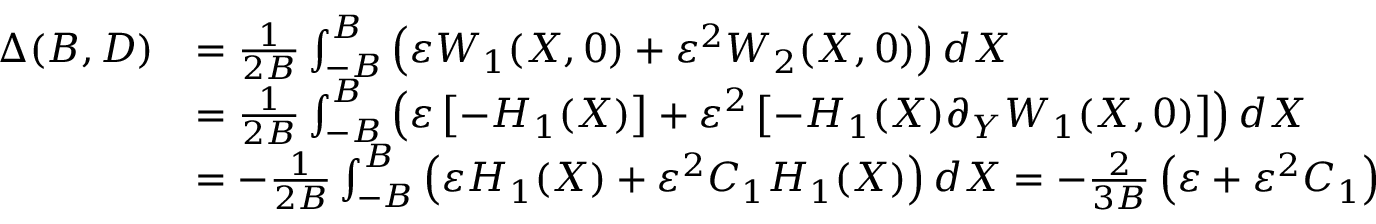<formula> <loc_0><loc_0><loc_500><loc_500>\begin{array} { r l } { \Delta ( B , D ) } & { = \frac { 1 } { 2 B } \int _ { - B } ^ { B } \left ( \varepsilon W _ { 1 } ( X , 0 ) + \varepsilon ^ { 2 } W _ { 2 } ( X , 0 ) \right ) d X } \\ & { = \frac { 1 } { 2 B } \int _ { - B } ^ { B } \left ( \varepsilon \left [ - H _ { 1 } ( X ) \right ] + \varepsilon ^ { 2 } \left [ - H _ { 1 } ( X ) \partial _ { Y } W _ { 1 } ( X , 0 ) \right ] \right ) d X } \\ & { = - \frac { 1 } { 2 B } \int _ { - B } ^ { B } \left ( \varepsilon H _ { 1 } ( X ) + \varepsilon ^ { 2 } C _ { 1 } H _ { 1 } ( X ) \right ) d X = - \frac { 2 } { 3 B } \left ( \varepsilon + \varepsilon ^ { 2 } C _ { 1 } \right ) } \end{array}</formula> 